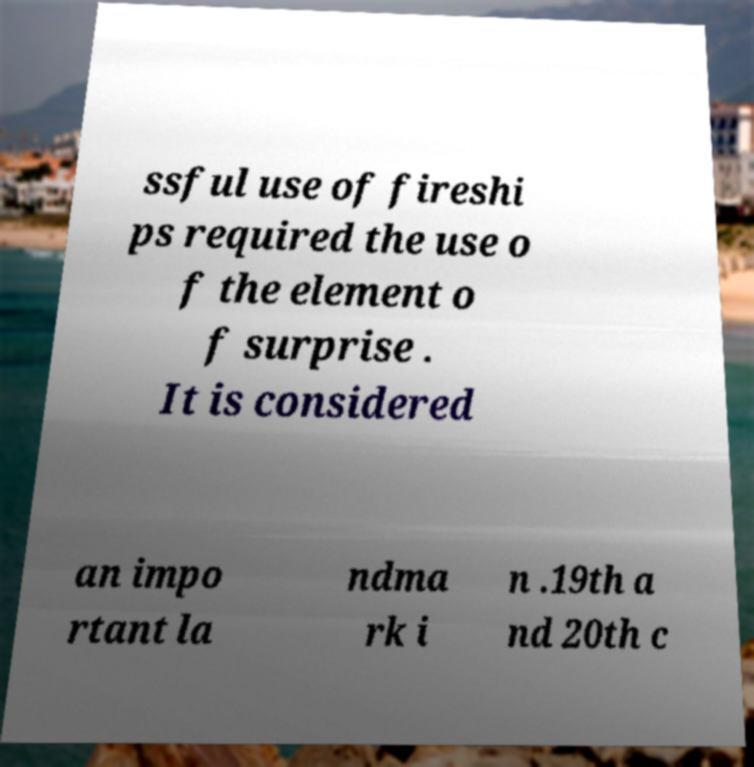Please read and relay the text visible in this image. What does it say? ssful use of fireshi ps required the use o f the element o f surprise . It is considered an impo rtant la ndma rk i n .19th a nd 20th c 